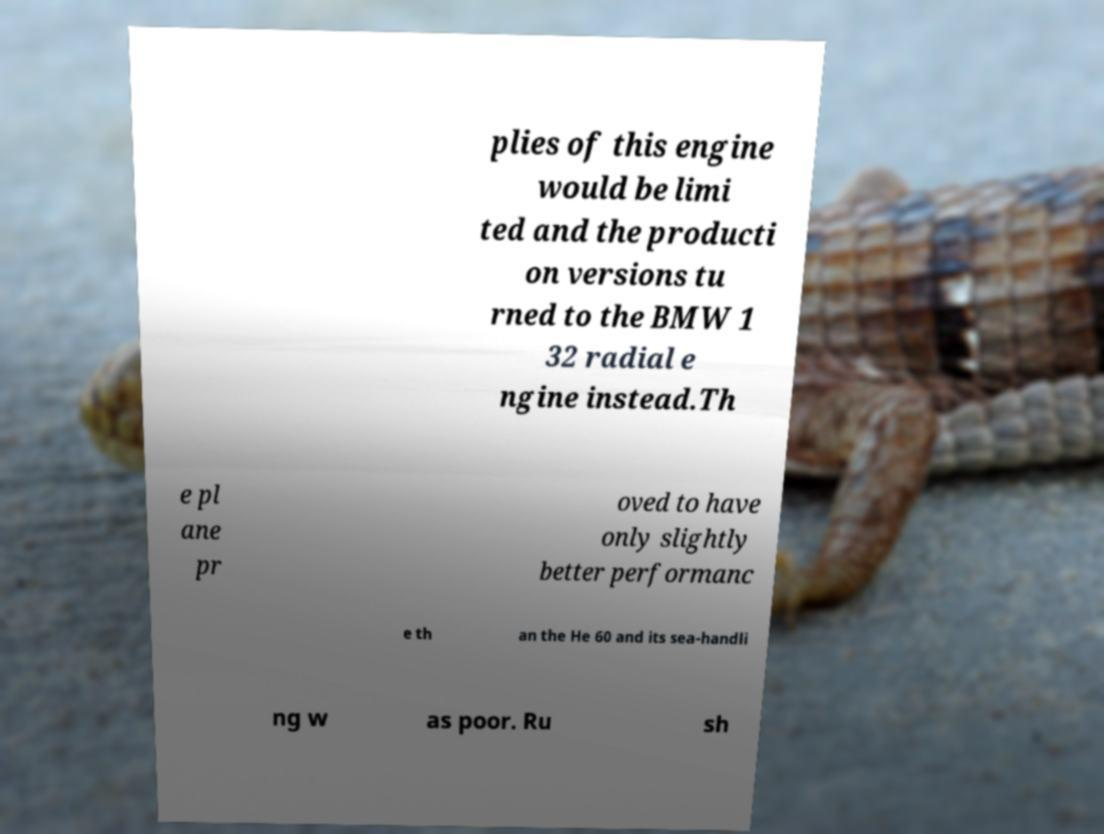I need the written content from this picture converted into text. Can you do that? plies of this engine would be limi ted and the producti on versions tu rned to the BMW 1 32 radial e ngine instead.Th e pl ane pr oved to have only slightly better performanc e th an the He 60 and its sea-handli ng w as poor. Ru sh 